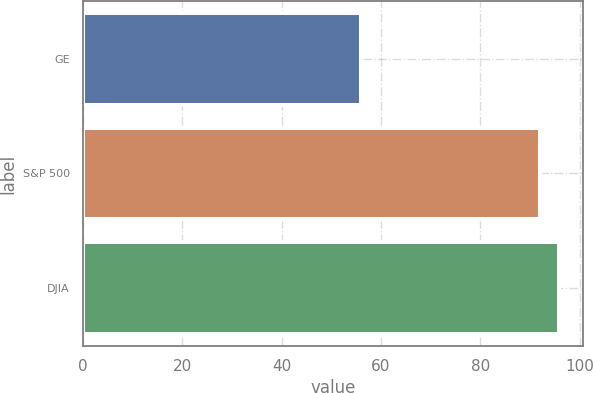Convert chart. <chart><loc_0><loc_0><loc_500><loc_500><bar_chart><fcel>GE<fcel>S&P 500<fcel>DJIA<nl><fcel>56<fcel>92<fcel>95.9<nl></chart> 